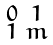Convert formula to latex. <formula><loc_0><loc_0><loc_500><loc_500>\begin{smallmatrix} 0 & 1 \\ 1 & m \end{smallmatrix}</formula> 